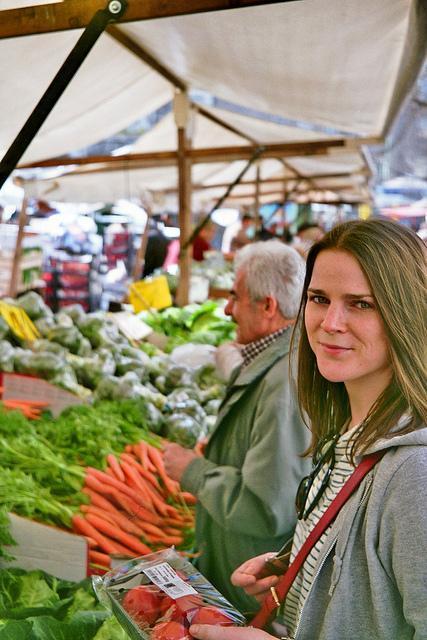How many people can be seen?
Give a very brief answer. 2. How many broccolis are there?
Give a very brief answer. 2. 